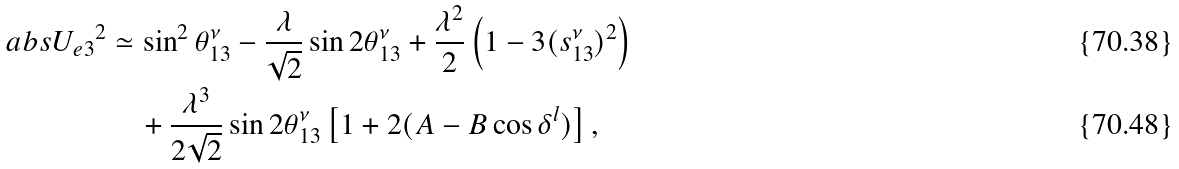Convert formula to latex. <formula><loc_0><loc_0><loc_500><loc_500>\ a b s { U _ { e 3 } } ^ { 2 } & \simeq \sin ^ { 2 } \theta ^ { \nu } _ { 1 3 } - \frac { \lambda } { \sqrt { 2 } } \sin 2 \theta ^ { \nu } _ { 1 3 } + \frac { \lambda ^ { 2 } } { 2 } \left ( 1 - 3 ( s ^ { \nu } _ { 1 3 } ) ^ { 2 } \right ) \\ & \quad + \frac { \lambda ^ { 3 } } { 2 \sqrt { 2 } } \sin 2 \theta ^ { \nu } _ { 1 3 } \left [ 1 + 2 ( A - B \cos \delta ^ { l } ) \right ] ,</formula> 